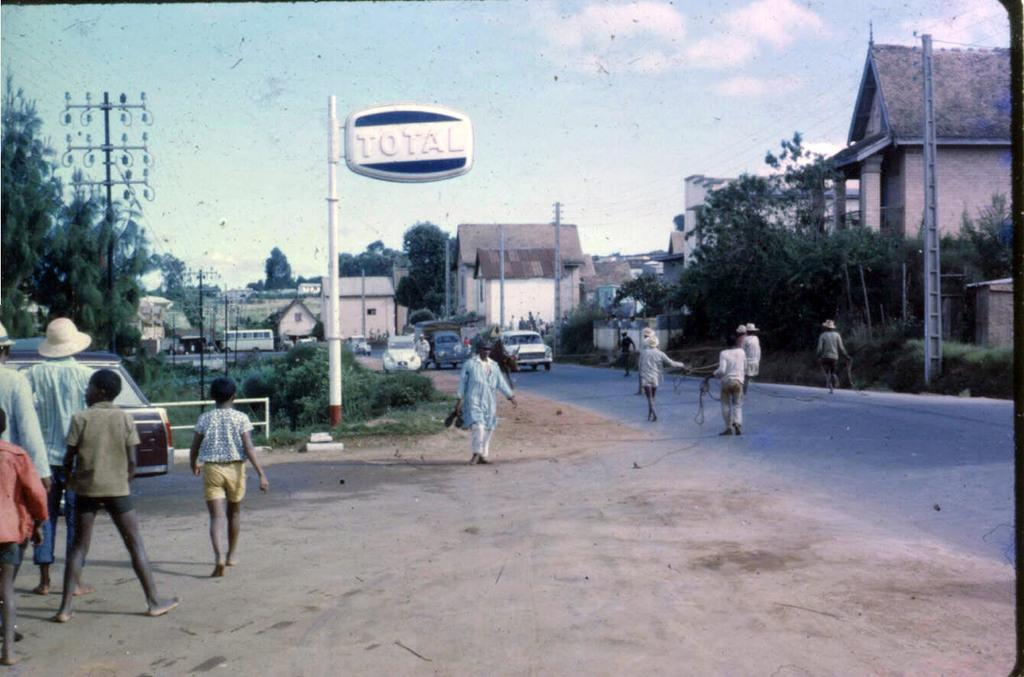What type of natural elements can be seen in the image? There are trees in the image. What type of man-made structures can be seen in the image? There are buildings in the image. What architectural features are present in the image? There are windows and poles in the image. What type of infrastructure is present in the image? There are current poles and wires in the image. What other objects can be seen in the image? There is a board in the image. What type of transportation is present in the image? There are vehicles in the image. Are there any living beings present in the image? Yes, there are people in the image. What is the color of the sky in the image? The sky is white and blue in color. Can you see a hat on top of the trees in the image? There is no hat present on top of the trees in the image. Is there a bat flying near the buildings in the image? There is no bat present near the buildings in the image. Can you spot a toad hopping on the wires in the image? There is no toad present on the wires in the image. 